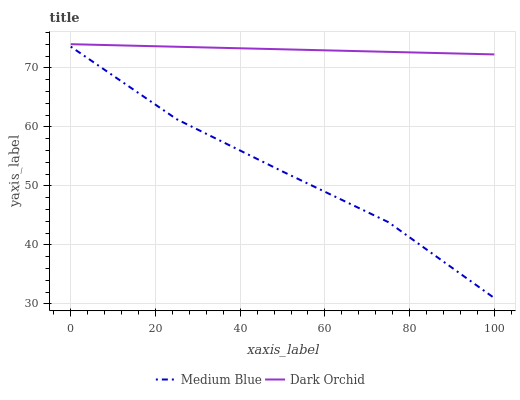Does Medium Blue have the minimum area under the curve?
Answer yes or no. Yes. Does Dark Orchid have the maximum area under the curve?
Answer yes or no. Yes. Does Dark Orchid have the minimum area under the curve?
Answer yes or no. No. Is Dark Orchid the smoothest?
Answer yes or no. Yes. Is Medium Blue the roughest?
Answer yes or no. Yes. Is Dark Orchid the roughest?
Answer yes or no. No. Does Medium Blue have the lowest value?
Answer yes or no. Yes. Does Dark Orchid have the lowest value?
Answer yes or no. No. Does Dark Orchid have the highest value?
Answer yes or no. Yes. Is Medium Blue less than Dark Orchid?
Answer yes or no. Yes. Is Dark Orchid greater than Medium Blue?
Answer yes or no. Yes. Does Medium Blue intersect Dark Orchid?
Answer yes or no. No. 